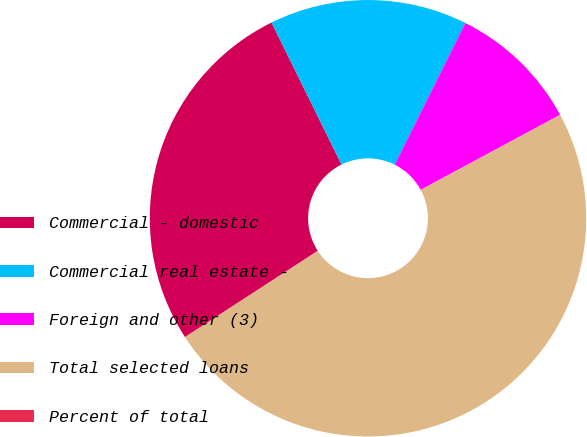Convert chart. <chart><loc_0><loc_0><loc_500><loc_500><pie_chart><fcel>Commercial - domestic<fcel>Commercial real estate -<fcel>Foreign and other (3)<fcel>Total selected loans<fcel>Percent of total<nl><fcel>26.87%<fcel>14.65%<fcel>9.78%<fcel>48.68%<fcel>0.02%<nl></chart> 